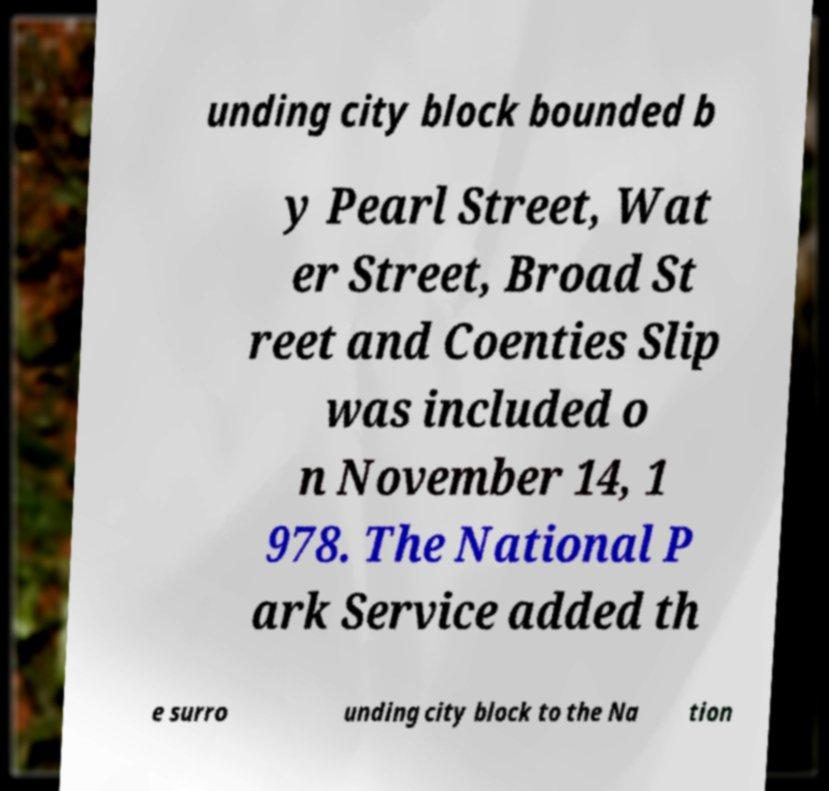Can you read and provide the text displayed in the image?This photo seems to have some interesting text. Can you extract and type it out for me? unding city block bounded b y Pearl Street, Wat er Street, Broad St reet and Coenties Slip was included o n November 14, 1 978. The National P ark Service added th e surro unding city block to the Na tion 